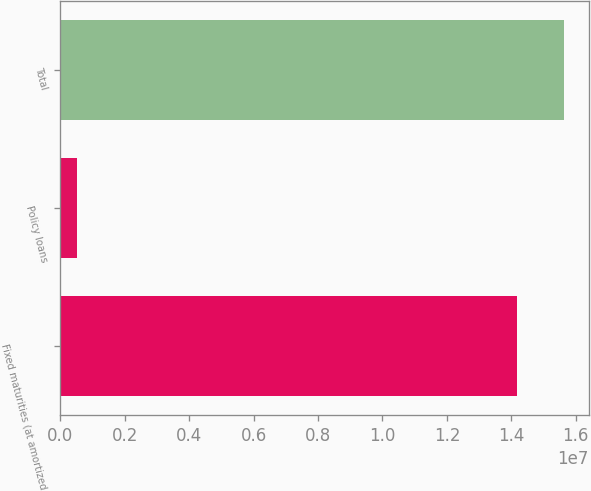Convert chart to OTSL. <chart><loc_0><loc_0><loc_500><loc_500><bar_chart><fcel>Fixed maturities (at amortized<fcel>Policy loans<fcel>Total<nl><fcel>1.4188e+07<fcel>507975<fcel>1.56194e+07<nl></chart> 